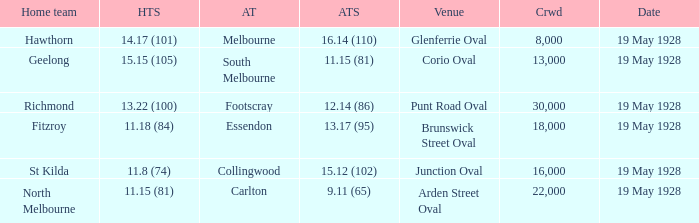What venue featured a crowd of over 30,000? None. 